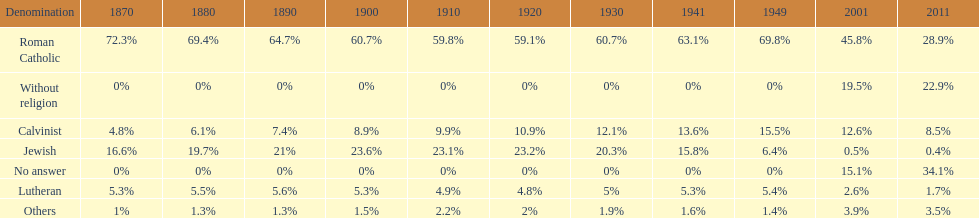Which religious denomination had a higher percentage in 1900, jewish or roman catholic? Roman Catholic. 